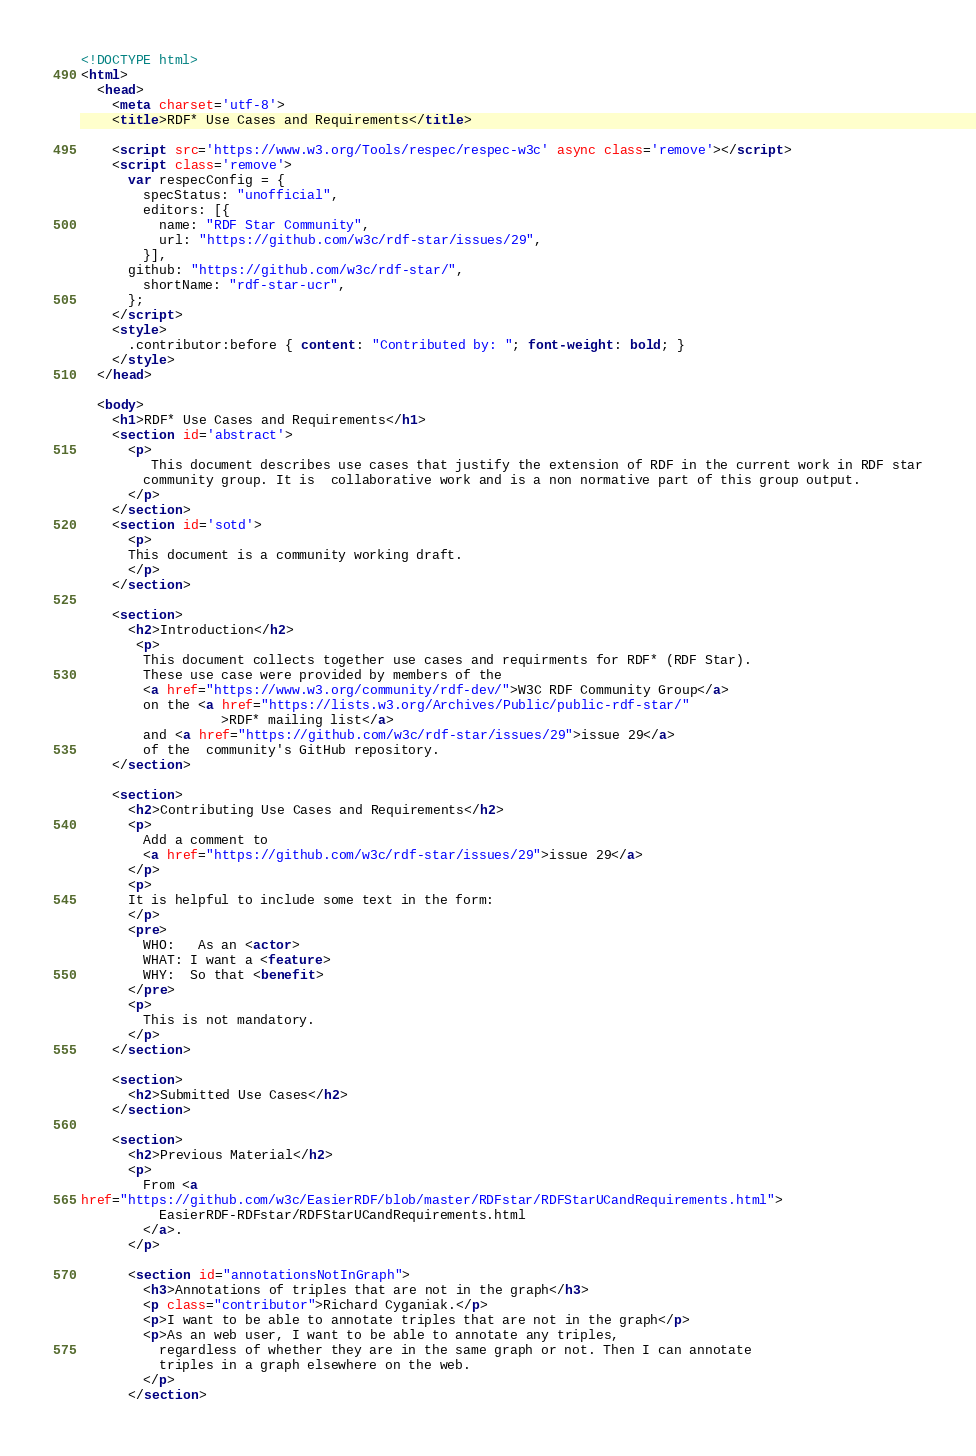<code> <loc_0><loc_0><loc_500><loc_500><_HTML_><!DOCTYPE html>
<html>
  <head>
    <meta charset='utf-8'>
    <title>RDF* Use Cases and Requirements</title>

    <script src='https://www.w3.org/Tools/respec/respec-w3c' async class='remove'></script>
    <script class='remove'>
      var respecConfig = {
        specStatus: "unofficial",
        editors: [{
          name: "RDF Star Community",
          url: "https://github.com/w3c/rdf-star/issues/29",
        }],
      github: "https://github.com/w3c/rdf-star/",
	    shortName: "rdf-star-ucr",
      };
    </script>
    <style>
      .contributor:before { content: "Contributed by: "; font-weight: bold; }
    </style>
  </head>
  
  <body>
    <h1>RDF* Use Cases and Requirements</h1>
    <section id='abstract'>
      <p>
         This document describes use cases that justify the extension of RDF in the current work in RDF star
        community group. It is  collaborative work and is a non normative part of this group output.   
      </p>
    </section>
    <section id='sotd'>
      <p>
      This document is a community working draft.
      </p>
    </section>

    <section>
      <h2>Introduction</h2>
       <p>
        This document collects together use cases and requirments for RDF* (RDF Star).
        These use case were provided by members of the 
        <a href="https://www.w3.org/community/rdf-dev/">W3C RDF Community Group</a>
        on the <a href="https://lists.w3.org/Archives/Public/public-rdf-star/"
                  >RDF* mailing list</a>
        and <a href="https://github.com/w3c/rdf-star/issues/29">issue 29</a>
        of the  community's GitHub repository.
    </section>

    <section>
      <h2>Contributing Use Cases and Requirements</h2>
      <p>
        Add a comment to 
        <a href="https://github.com/w3c/rdf-star/issues/29">issue 29</a>
      </p>
      <p>
      It is helpful to include some text in the form:
      </p>
      <pre>
        WHO:   As an <actor>
        WHAT: I want a <feature>
        WHY:  So that <benefit>
      </pre>       
      <p>
        This is not mandatory.
      </p>
    </section>

    <section>
      <h2>Submitted Use Cases</h2>
    </section>

    <section>
      <h2>Previous Material</h2>
      <p>
        From <a 
href="https://github.com/w3c/EasierRDF/blob/master/RDFstar/RDFStarUCandRequirements.html">
          EasierRDF-RDFstar/RDFStarUCandRequirements.html
        </a>.
      </p>

      <section id="annotationsNotInGraph">
        <h3>Annotations of triples that are not in the graph</h3>
        <p class="contributor">Richard Cyganiak.</p>
        <p>I want to be able to annotate triples that are not in the graph</p>
        <p>As an web user, I want to be able to annotate any triples,
          regardless of whether they are in the same graph or not. Then I can annotate
          triples in a graph elsewhere on the web.
        </p>
      </section>
</code> 